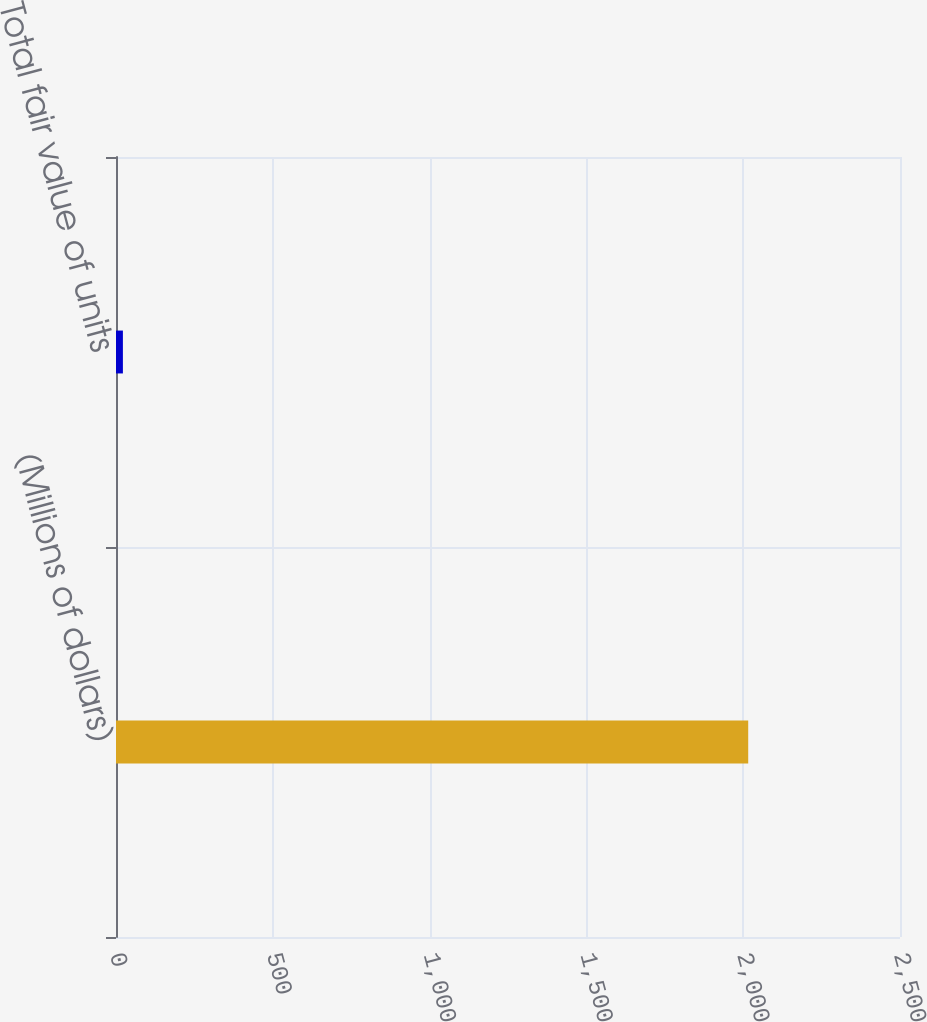<chart> <loc_0><loc_0><loc_500><loc_500><bar_chart><fcel>(Millions of dollars)<fcel>Total fair value of units<nl><fcel>2016<fcel>22<nl></chart> 